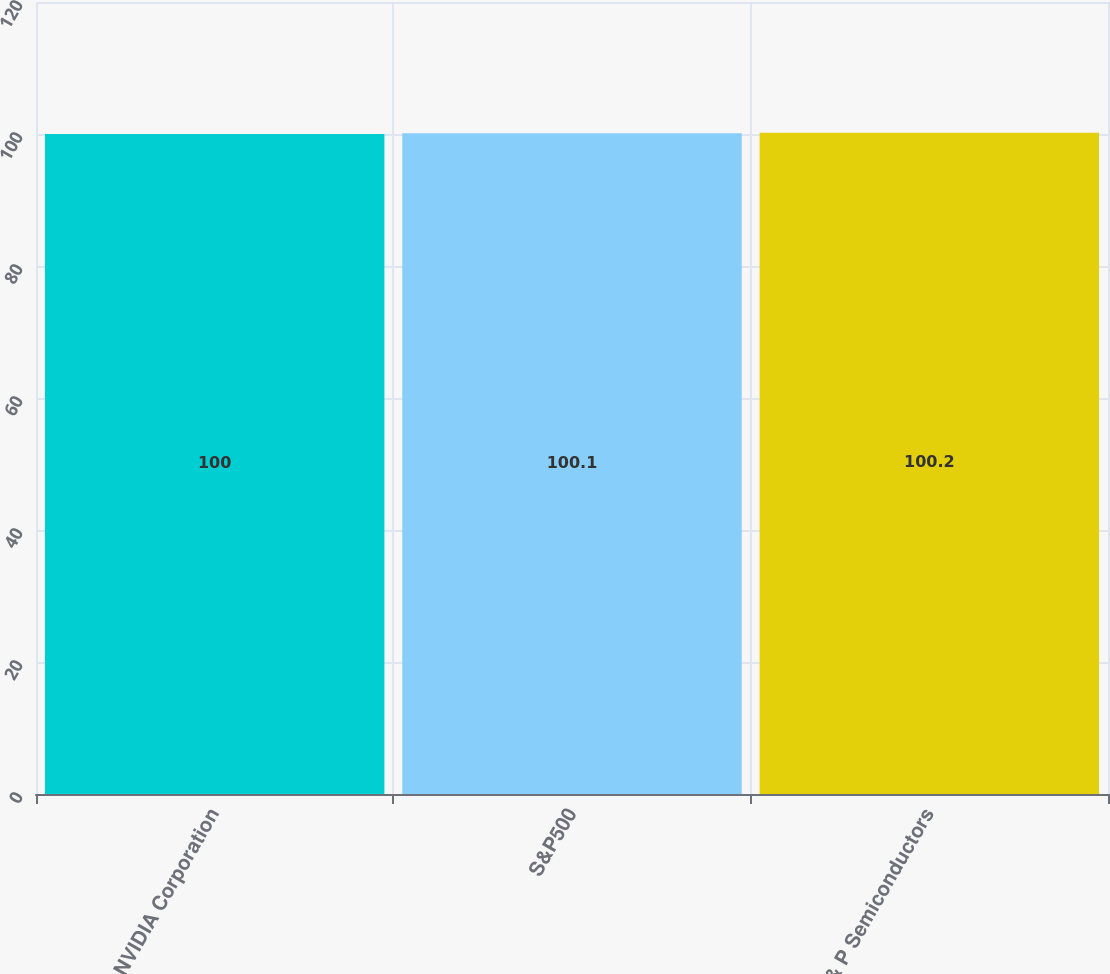Convert chart. <chart><loc_0><loc_0><loc_500><loc_500><bar_chart><fcel>NVIDIA Corporation<fcel>S&P500<fcel>S & P Semiconductors<nl><fcel>100<fcel>100.1<fcel>100.2<nl></chart> 